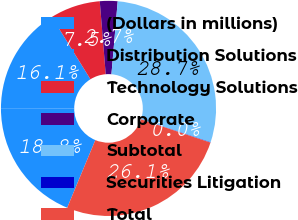Convert chart. <chart><loc_0><loc_0><loc_500><loc_500><pie_chart><fcel>(Dollars in millions)<fcel>Distribution Solutions<fcel>Technology Solutions<fcel>Corporate<fcel>Subtotal<fcel>Securities Litigation<fcel>Total<nl><fcel>18.76%<fcel>16.14%<fcel>7.53%<fcel>2.66%<fcel>28.74%<fcel>0.05%<fcel>26.12%<nl></chart> 